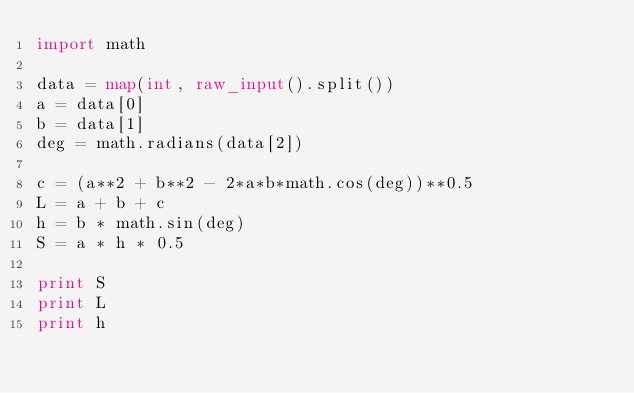Convert code to text. <code><loc_0><loc_0><loc_500><loc_500><_Python_>import math

data = map(int, raw_input().split())
a = data[0]
b = data[1]
deg = math.radians(data[2])

c = (a**2 + b**2 - 2*a*b*math.cos(deg))**0.5
L = a + b + c
h = b * math.sin(deg)
S = a * h * 0.5

print S
print L
print h</code> 